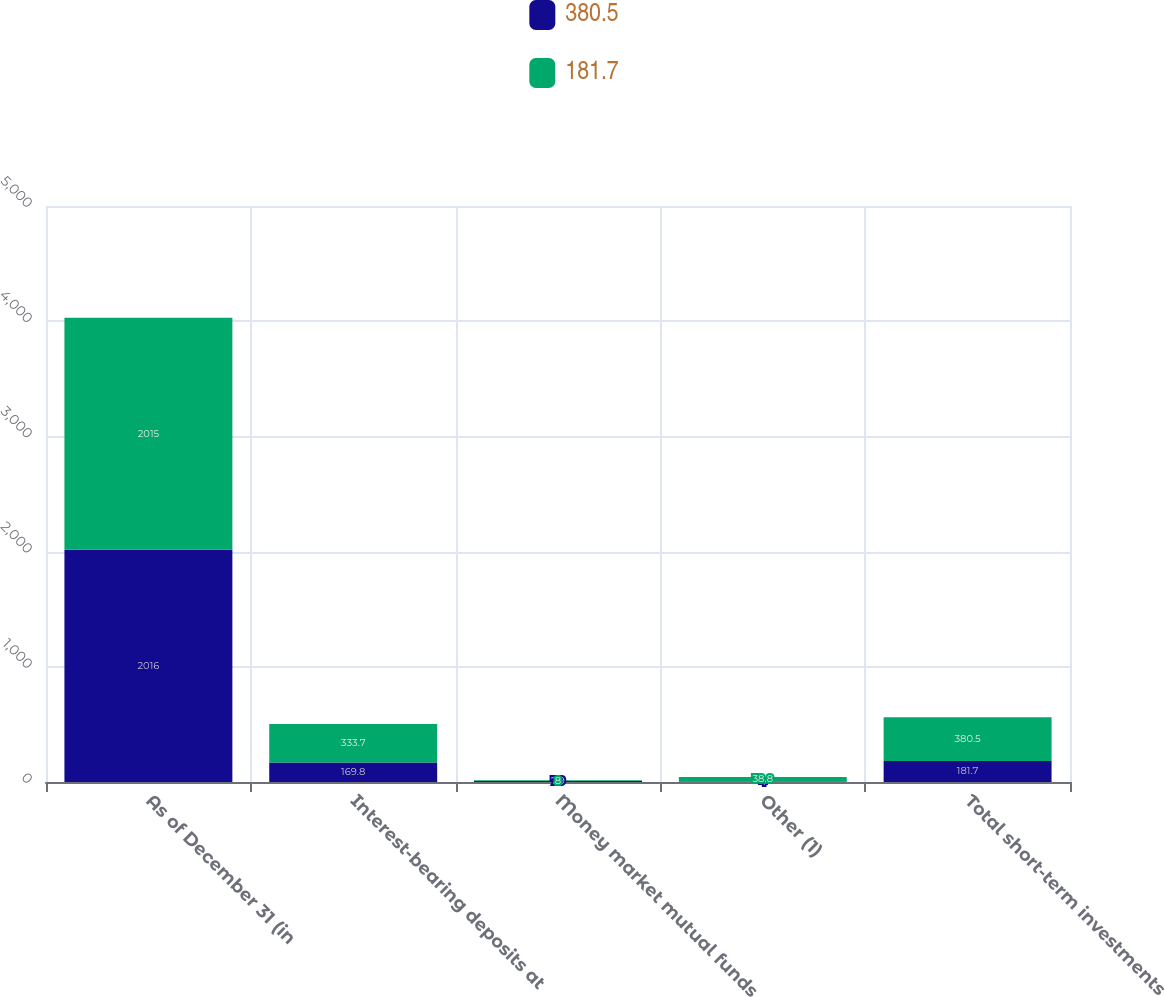<chart> <loc_0><loc_0><loc_500><loc_500><stacked_bar_chart><ecel><fcel>As of December 31 (in<fcel>Interest-bearing deposits at<fcel>Money market mutual funds<fcel>Other (1)<fcel>Total short-term investments<nl><fcel>380.5<fcel>2016<fcel>169.8<fcel>7.9<fcel>4<fcel>181.7<nl><fcel>181.7<fcel>2015<fcel>333.7<fcel>8<fcel>38.8<fcel>380.5<nl></chart> 